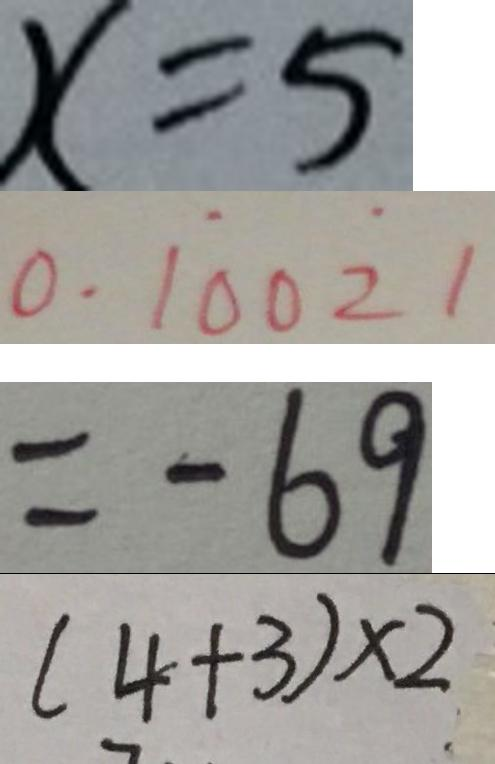<formula> <loc_0><loc_0><loc_500><loc_500>x = 5 
 0 . 1 \dot { 0 } 0 \dot { 2 } 1 
 = - 6 9 
 ( 4 + 3 ) \times 2</formula> 